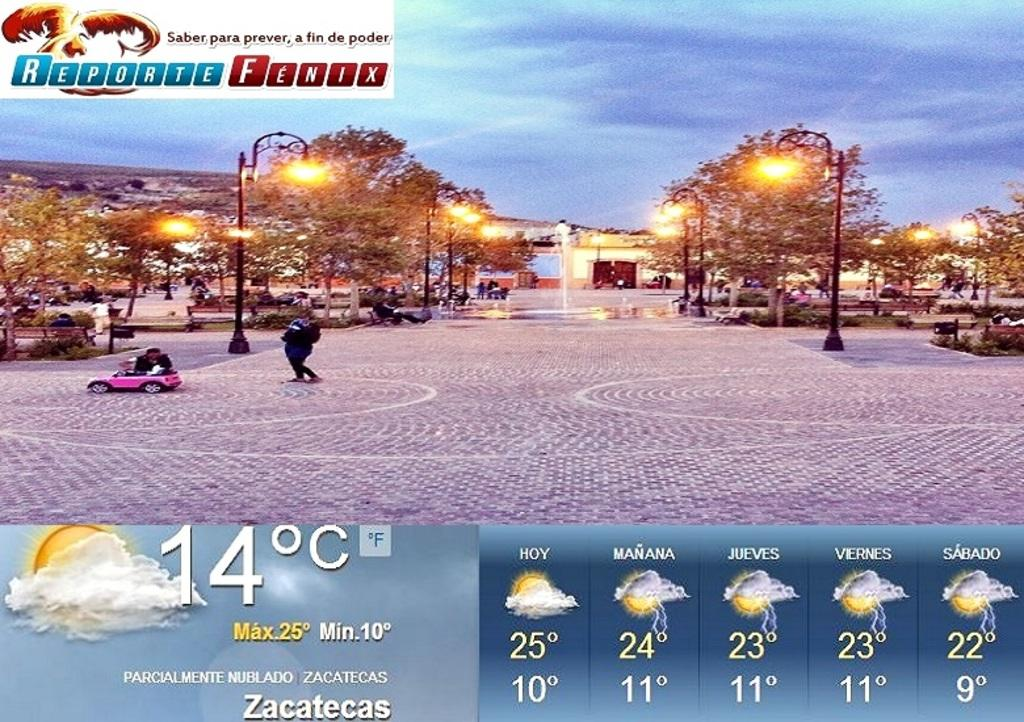<image>
Write a terse but informative summary of the picture. The five day forecast is shown below an outdoor scene by Reporte Fenix. 